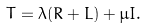Convert formula to latex. <formula><loc_0><loc_0><loc_500><loc_500>T = \lambda ( R + L ) + \mu I .</formula> 